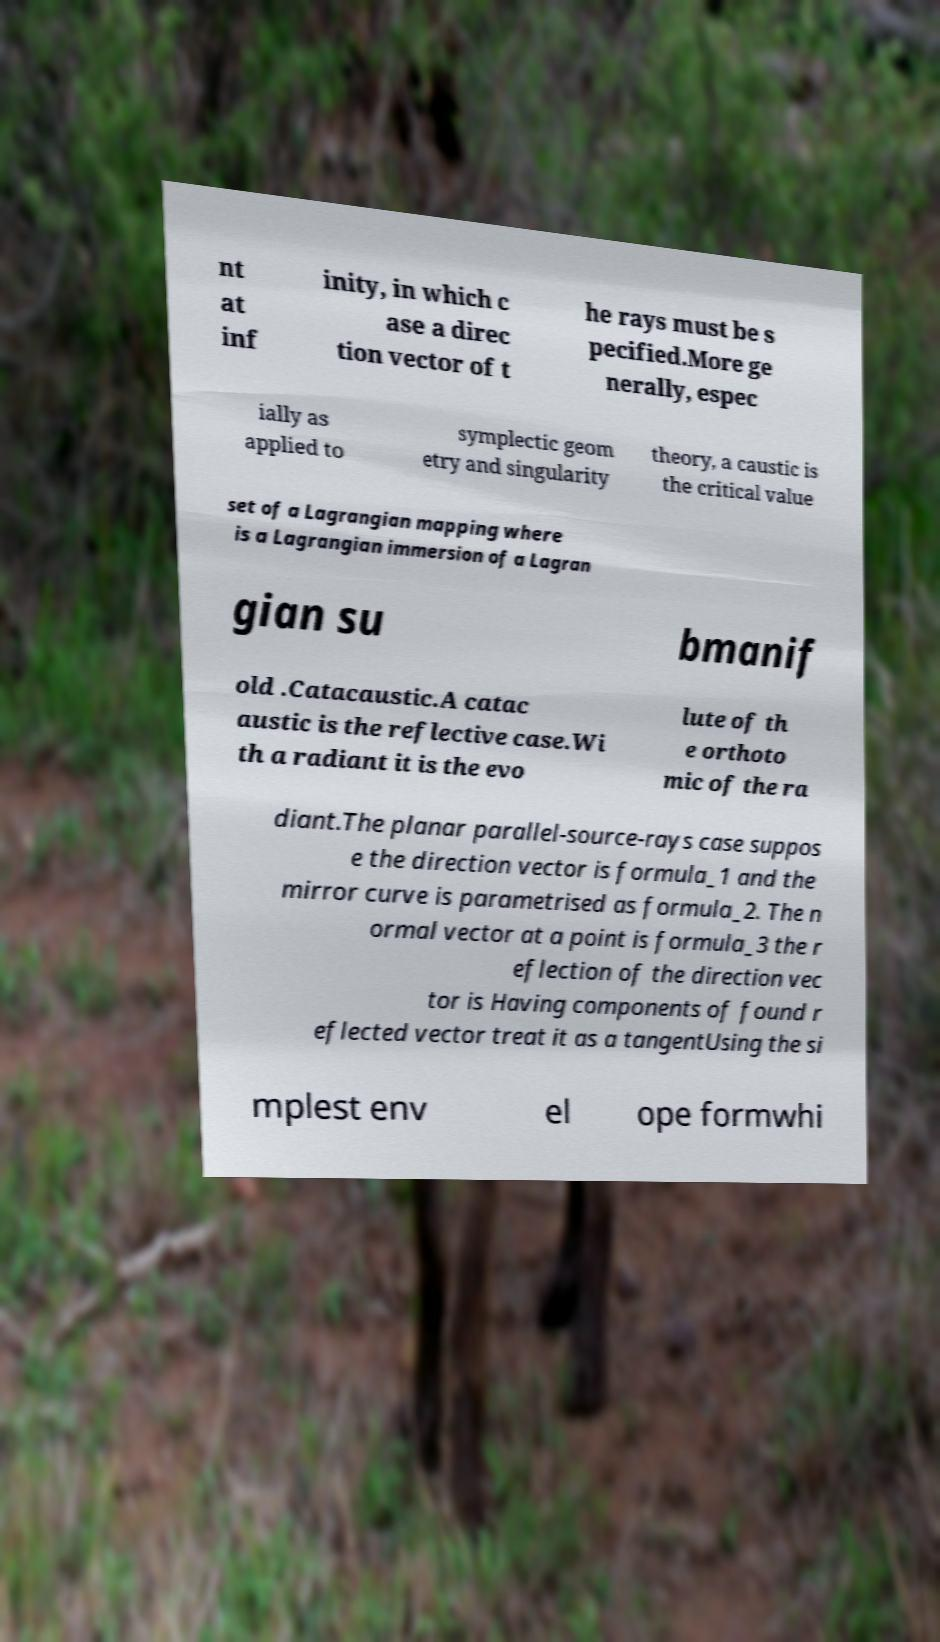Could you assist in decoding the text presented in this image and type it out clearly? nt at inf inity, in which c ase a direc tion vector of t he rays must be s pecified.More ge nerally, espec ially as applied to symplectic geom etry and singularity theory, a caustic is the critical value set of a Lagrangian mapping where is a Lagrangian immersion of a Lagran gian su bmanif old .Catacaustic.A catac austic is the reflective case.Wi th a radiant it is the evo lute of th e orthoto mic of the ra diant.The planar parallel-source-rays case suppos e the direction vector is formula_1 and the mirror curve is parametrised as formula_2. The n ormal vector at a point is formula_3 the r eflection of the direction vec tor is Having components of found r eflected vector treat it as a tangentUsing the si mplest env el ope formwhi 